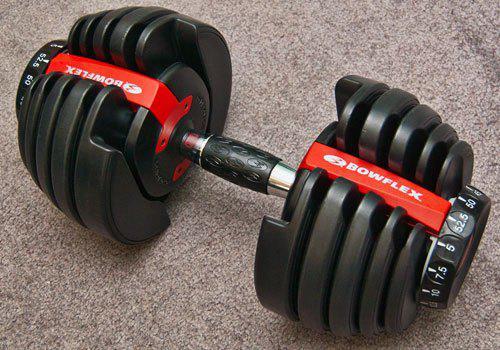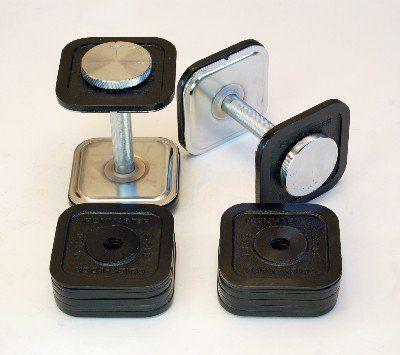The first image is the image on the left, the second image is the image on the right. Considering the images on both sides, is "There is a single dumbbell in the left image." valid? Answer yes or no. Yes. The first image is the image on the left, the second image is the image on the right. For the images displayed, is the sentence "There is a total of three dumbells with six sets of circle weights on it." factually correct? Answer yes or no. No. 